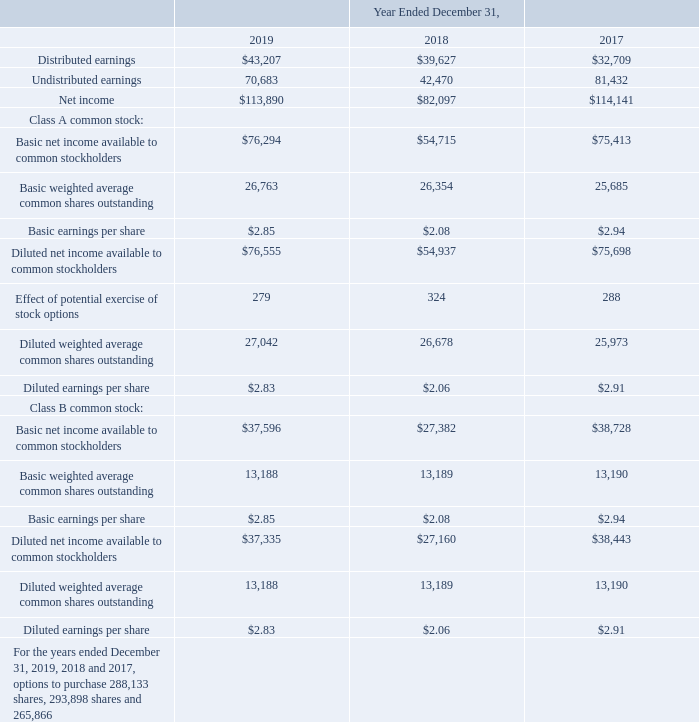6. Earnings per Share
Under ASC 260, Earnings per Share, the two-class method is an earnings allocation formula that determines earnings per share for each class of common stock according to dividends declared (or accumulated) and participation rights in undistributed earnings. Under that method, basic and diluted earnings per share data are presented for each class of common stock.
In applying the two-class method, we determined that undistributed earnings should be allocated equally on a per share basis between Class A and Class B common stock. Under our Certificate of Incorporation, the holders of the common stock are entitled to participate ratably, on a share-for-share basis as if all shares of common stock were of a single class, in such dividends, as may be declared by the Board of Directors. During the years ended December 31, 2019, 2018 and 2017, we declared and paid quarterly dividends, in the amount of $0.27, $0.25 and $0.21 per share on both classes of common stock.
Basic earnings per share has been computed by dividing net income available to common stockholders by the weighted average number of shares of common stock outstanding during each period. Shares issued during the period and shares reacquired during the period are weighted for the portion of the period in which the shares were outstanding. Diluted earnings per share have been computed in a manner consistent with that of basic earnings per share while giving effect to all potentially dilutive common shares that were outstanding during each period.
The net income available to common stockholders and weighted average number of common shares outstanding used to compute basic and diluted earnings per share for each class of common stock are as follows (in thousands, except per share amounts):
For the years ended December 31, 2019, 2018 and 2017, options to purchase 288,133 shares, 293,898 shares and 265,866 shares, respectively, were outstanding but not included in the computation of diluted earnings per share because the options' effect would have been anti-dilutive. For the years ended December 31, 2019, 2018 and 2017, there were 338,748 shares, 420,524 shares and 463,800 shares, respectively, issued from the exercise of stock options.
How have basic earnings per share been computed during each period? By dividing net income available to common stockholders by the weighted average number of shares of common stock outstanding. How many options to purchase shares were outstanding for the years ended December 31, 2019, and 2018, respectively? 288,133, 293,898. What does the two-class method mean under ASC 360? An earnings allocation formula that determines earnings per share for each class of common stock according to dividends declared (or accumulated) and participation rights in undistributed earnings. What is the ratio of net income for the year ended December 31, 2018, to 2019? $82,097/$113,890 
Answer: 0.72. What is the percentage change in diluted earnings per share for Class A common stock from the year ended December 31, 2018, to 2019?
Answer scale should be: percent. ($2.83-$2.06)/$2.06 
Answer: 37.38. What is the percentage change in diluted earnings per share for Class B common stock from the year ended December 31, 2017, to 2018?
Answer scale should be: percent. ($2.06-$2.91)/$2.91 
Answer: -29.21. 